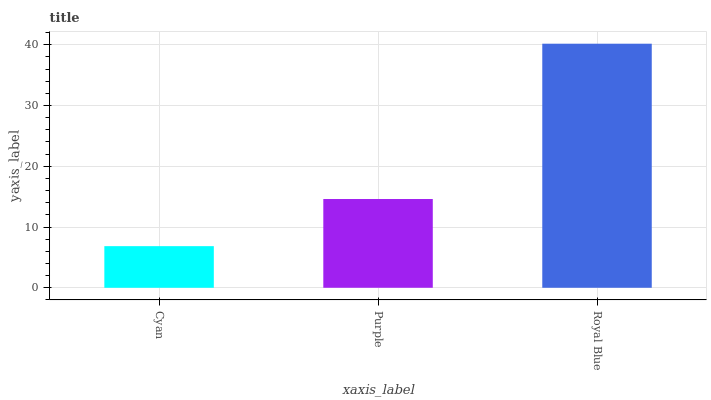Is Cyan the minimum?
Answer yes or no. Yes. Is Royal Blue the maximum?
Answer yes or no. Yes. Is Purple the minimum?
Answer yes or no. No. Is Purple the maximum?
Answer yes or no. No. Is Purple greater than Cyan?
Answer yes or no. Yes. Is Cyan less than Purple?
Answer yes or no. Yes. Is Cyan greater than Purple?
Answer yes or no. No. Is Purple less than Cyan?
Answer yes or no. No. Is Purple the high median?
Answer yes or no. Yes. Is Purple the low median?
Answer yes or no. Yes. Is Royal Blue the high median?
Answer yes or no. No. Is Royal Blue the low median?
Answer yes or no. No. 